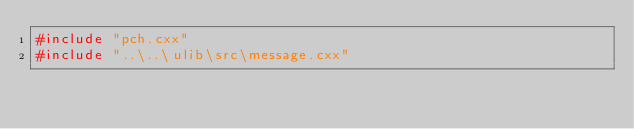<code> <loc_0><loc_0><loc_500><loc_500><_C++_>#include "pch.cxx"  
#include "..\..\ulib\src\message.cxx" 
</code> 